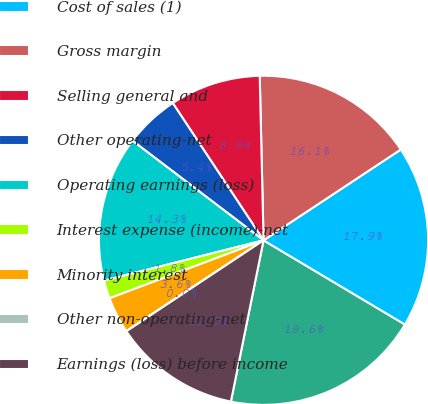Convert chart. <chart><loc_0><loc_0><loc_500><loc_500><pie_chart><fcel>Net sales (1)<fcel>Cost of sales (1)<fcel>Gross margin<fcel>Selling general and<fcel>Other operating-net<fcel>Operating earnings (loss)<fcel>Interest expense (income)-net<fcel>Minority interest<fcel>Other non-operating-net<fcel>Earnings (loss) before income<nl><fcel>19.63%<fcel>17.85%<fcel>16.07%<fcel>8.93%<fcel>5.36%<fcel>14.28%<fcel>1.79%<fcel>3.58%<fcel>0.01%<fcel>12.5%<nl></chart> 